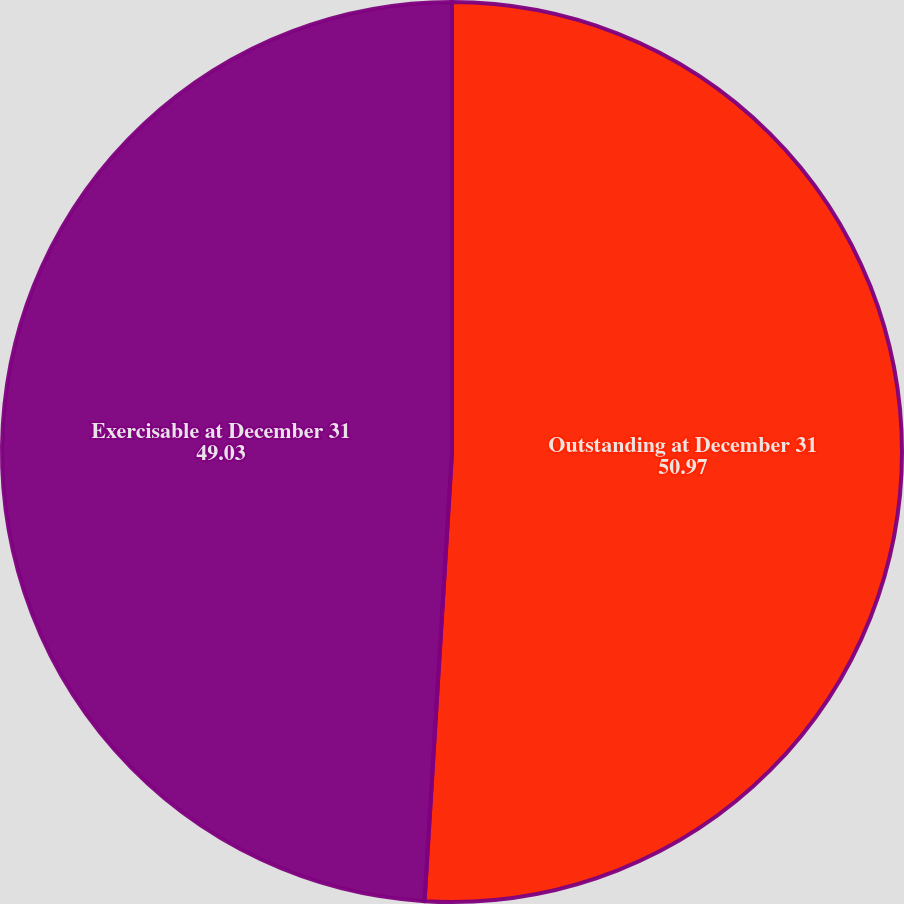Convert chart. <chart><loc_0><loc_0><loc_500><loc_500><pie_chart><fcel>Outstanding at December 31<fcel>Exercisable at December 31<nl><fcel>50.97%<fcel>49.03%<nl></chart> 